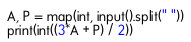Convert code to text. <code><loc_0><loc_0><loc_500><loc_500><_Python_>A, P = map(int, input().split(" "))
print(int((3*A + P) / 2))</code> 